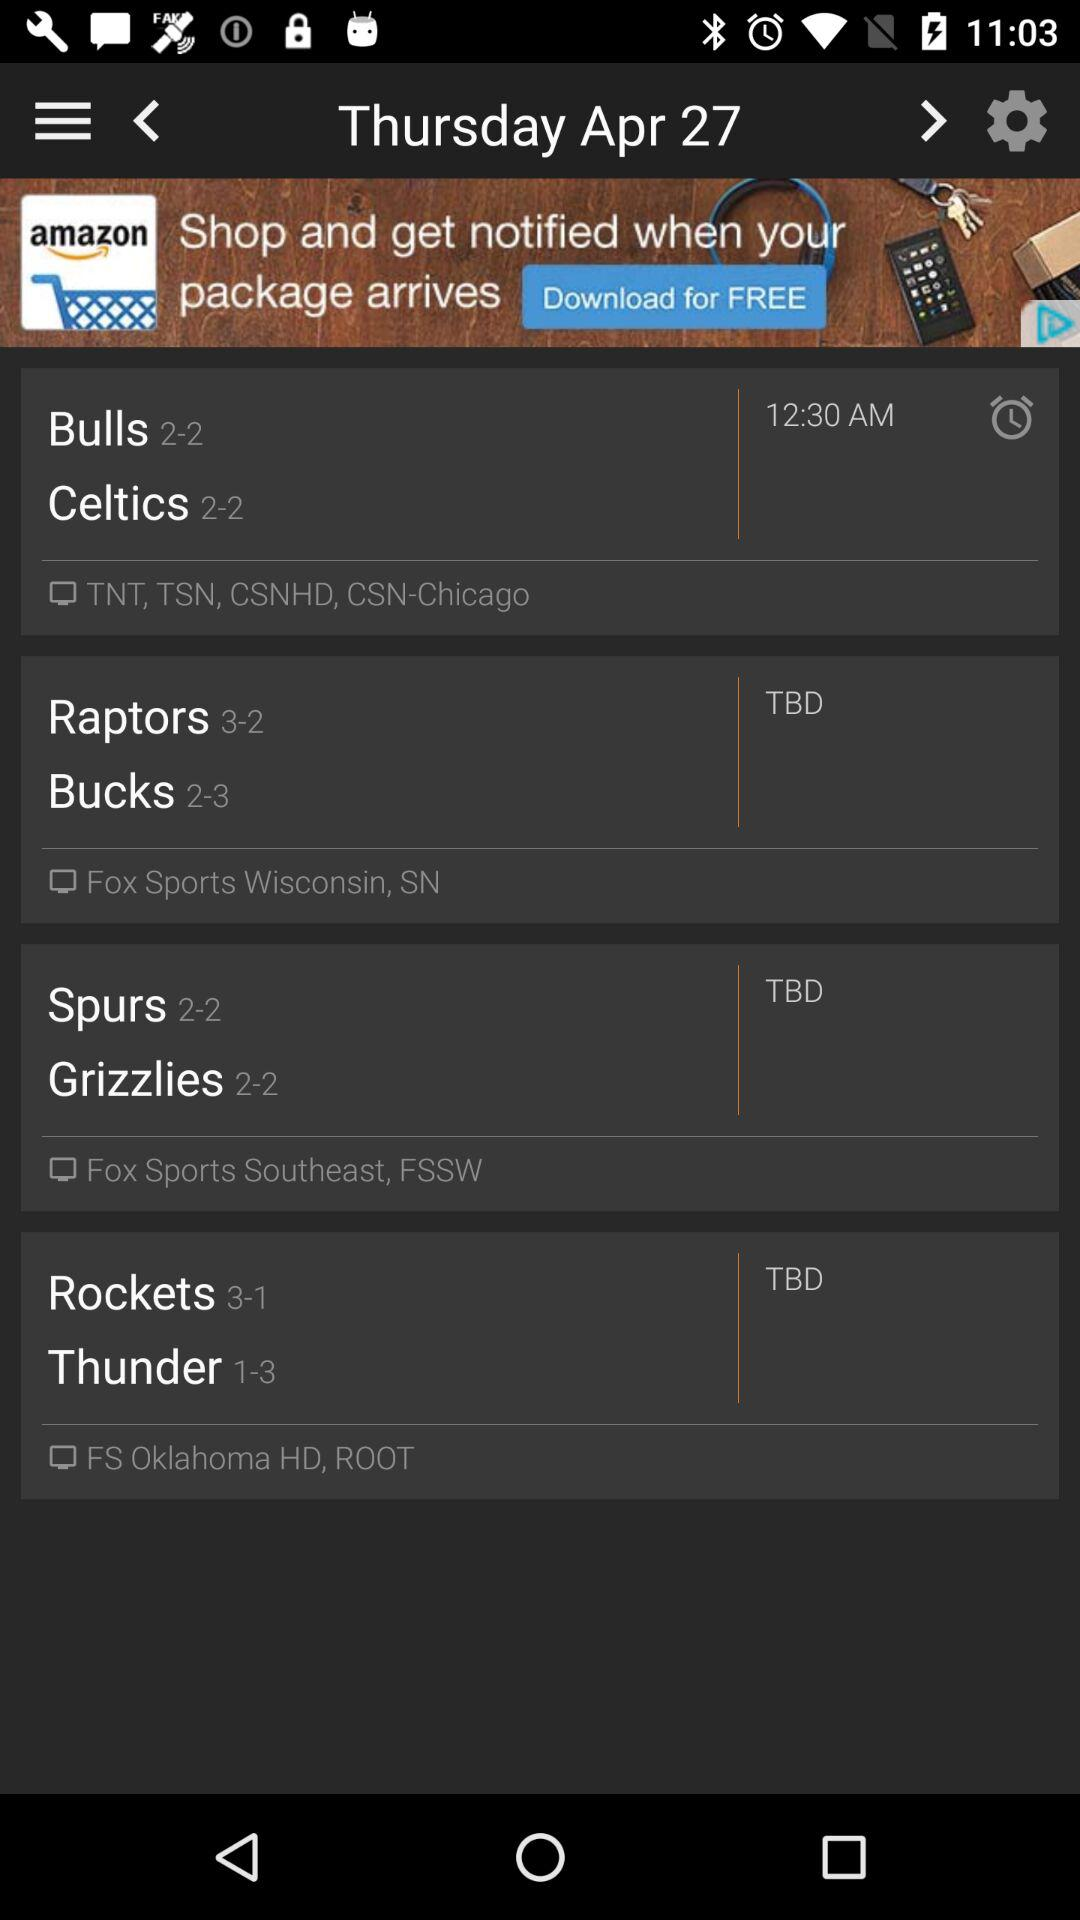What is the score of the bucks? The score is "2-3". 